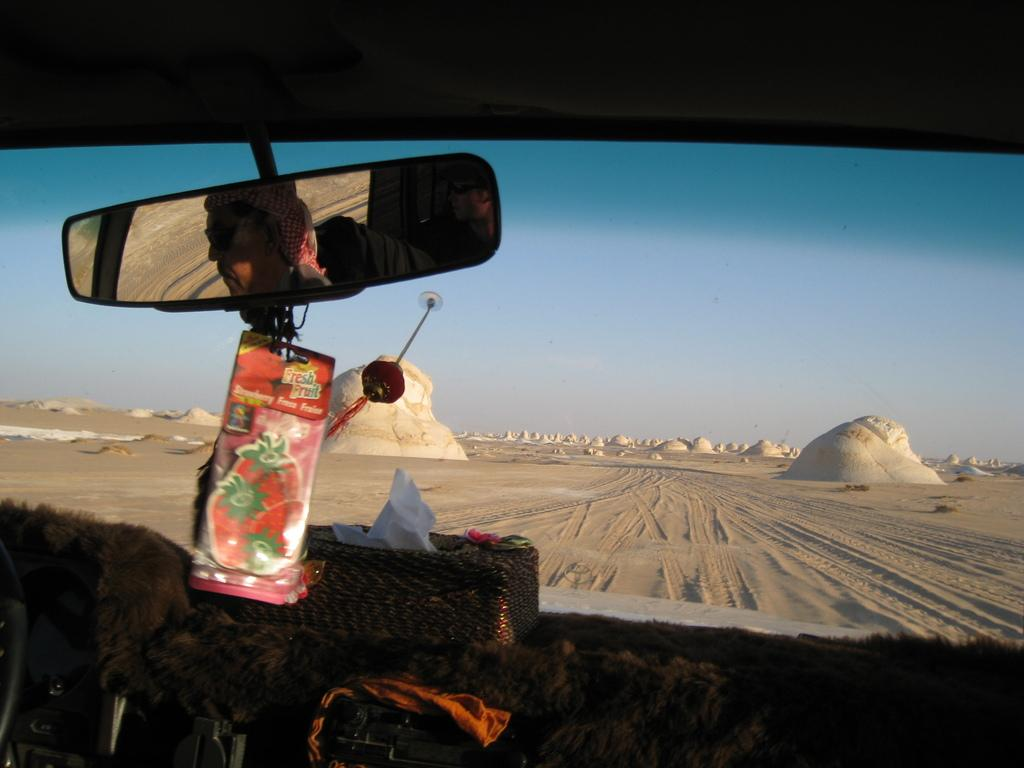What object is visible in the image that is commonly used for wiping hands or faces? There is a paper napkin box in the image. What object is visible in the image that is typically found in a car? There is a rear view mirror in the image. Where is the image taken from? The image is taken from the dashboard of a car. What can be seen through the windshield in the image? There are objects visible on the road through the windshield. What type of humor can be seen in the image? There is no humor present in the image; it is a straightforward view from the dashboard of a car. 